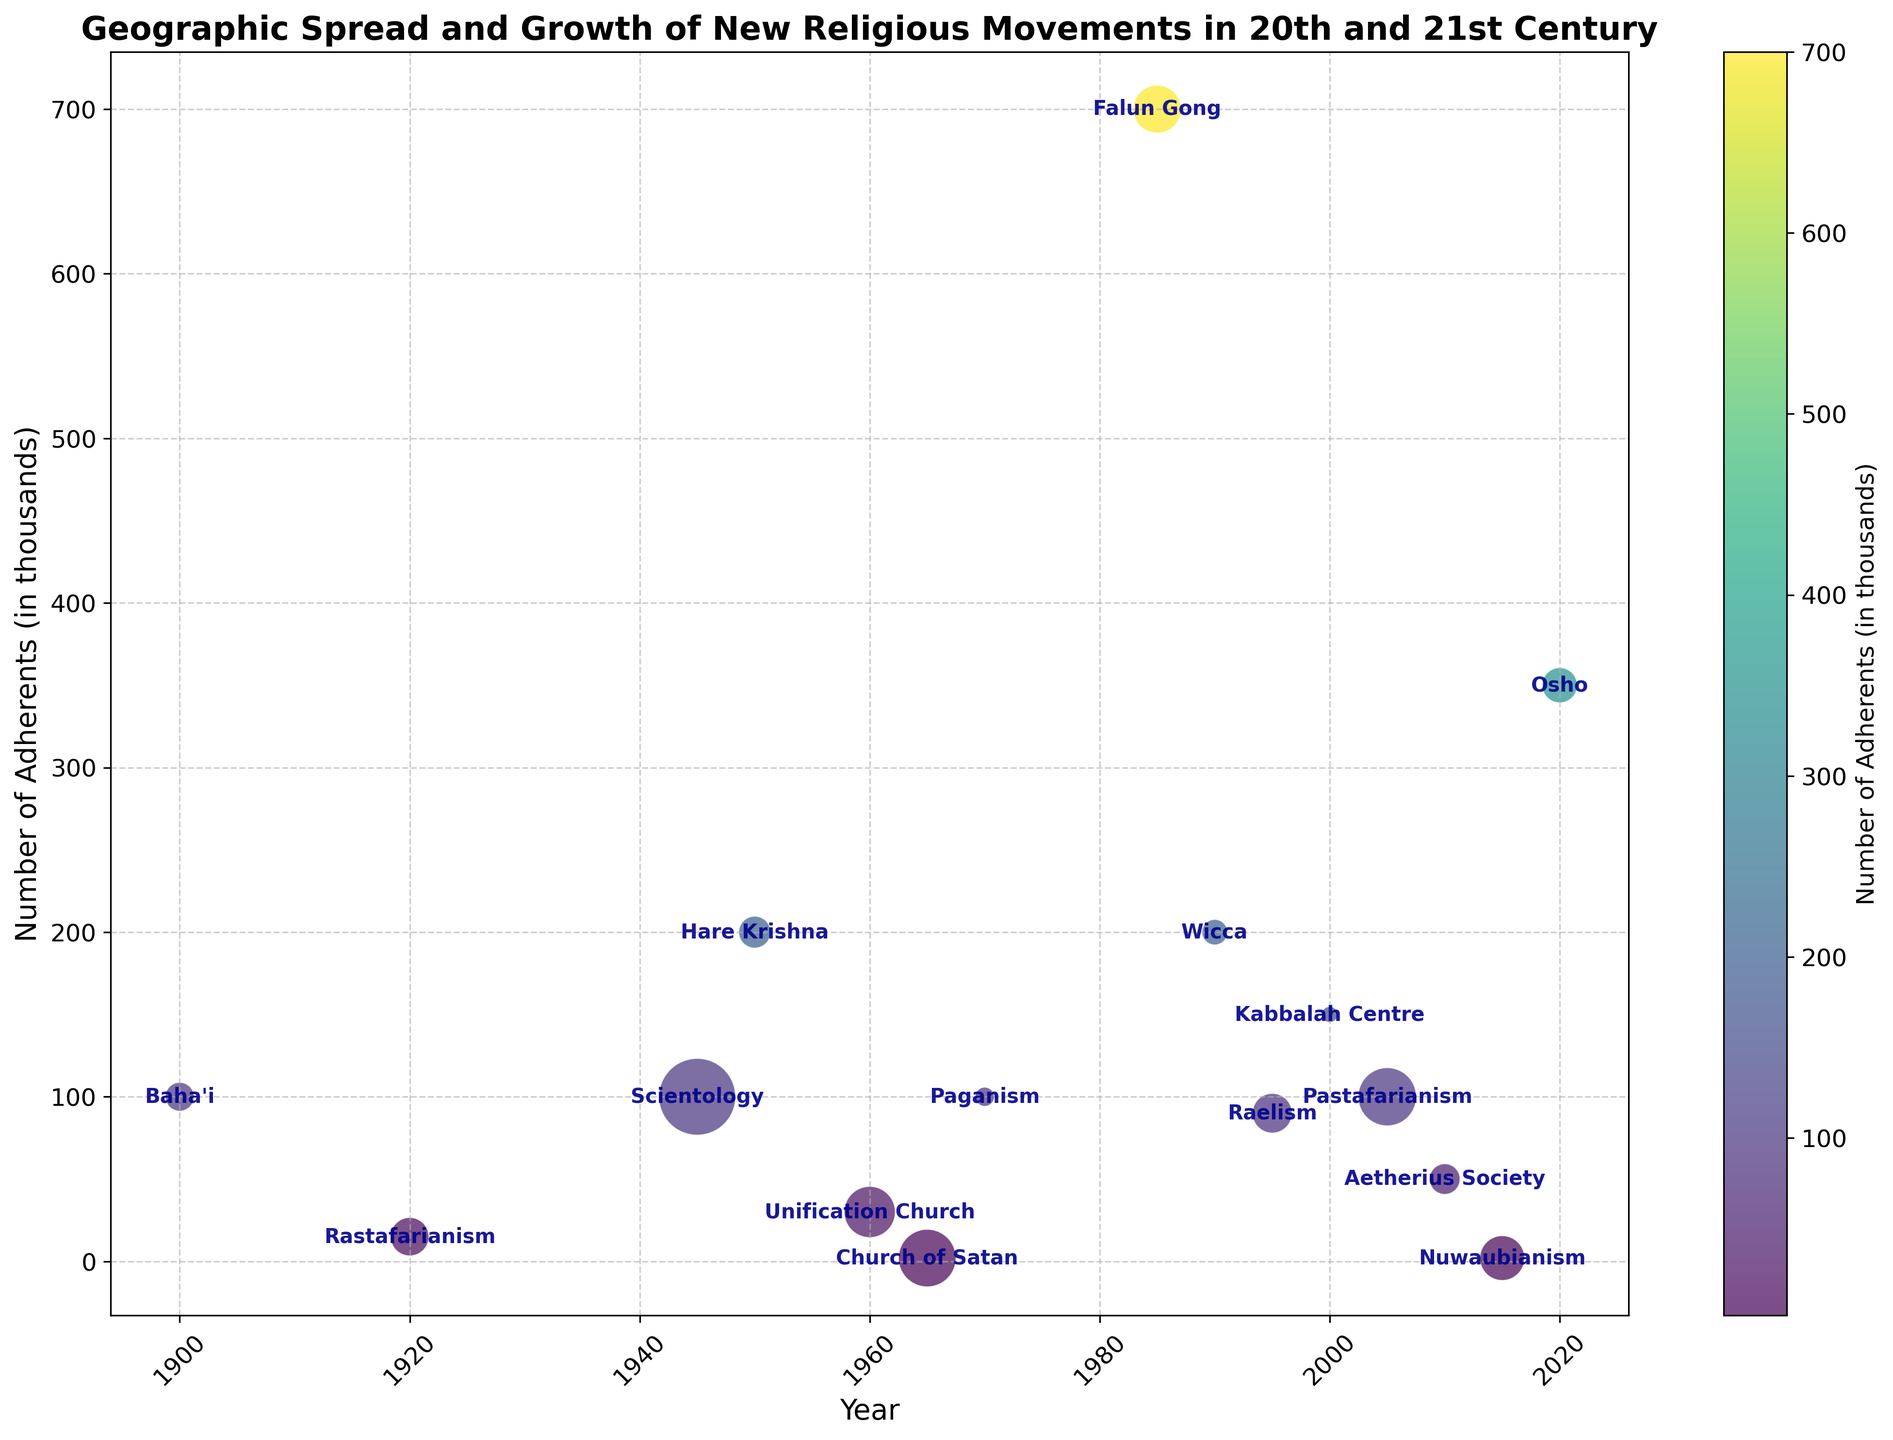Which religious movement had the highest number of adherents in 2020? Looking at the data points for the year 2020, the Osho movement has the highest bubble, indicating it has the largest number of adherents.
Answer: Osho How does the growth rate of Scientology compare to that of Wicca? Scientology's bubble size is significantly larger than Wicca's. This implies that Scientology has a higher growth rate than Wicca.
Answer: Scientology has a higher growth rate What is the total number of adherents for movements originating from North America in the 21st century? Summing up the number of adherents from the chart for North American movements in the 21st century (Kabbalah Centre - 150000, Nuwaubianism - 2000), the total is 152000 adherents.
Answer: 152000 Which region has the most diversity in new religious movements according to the chart? North America has the most diverse set of new religious movements visible in the plot, including Scientology, Church of Satan, Wicca, Kabbalah Centre, and Nuwaubianism. This is evident from the multiple data points scattered over the timeline for North America.
Answer: North America What can be inferred about the growth rate of Pastafarianism by looking at bubble size and color? Pastafarianism has one of the largest bubble sizes and is brightly colored, indicating a high growth rate and a significant number of adherents.
Answer: High growth rate, significant number of adherents Compare the number of adherents and growth rates of Rastafarianism and Unification Church. Rastafarianism has fewer adherents but a higher growth rate compared to the Unification Church, as indicated by the smaller but more vividly colored bubble for Rastafarianism.
Answer: Rastafarianism has fewer adherents but a higher growth rate Which religious movement experienced the sharpest increase in growth rate post-1950? By visually examining the bubbles after 1950, Scientology has one of the largest bubbles right after its origin year, indicating a rapid increase in growth rate shortly after its inception.
Answer: Scientology How does the geographic spread of Paganism compare with Raelism in terms of the number of adherents? Both appear in Europe, but Paganism has a larger bubble compared to Raelism, indicating a higher number of adherents.
Answer: Paganism has more adherents What is common in terms of growth rate among movements originated in East Asia (Falun Gong and Unification Church)? Both have relatively large bubbles indicating a substantial growth rate, with Falun Gong at 7.5 and Unification Church at 8.
Answer: Both have high growth rates 